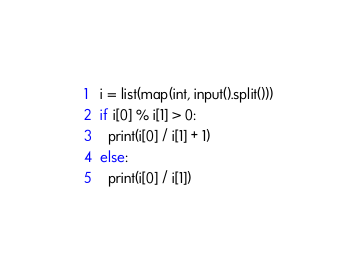<code> <loc_0><loc_0><loc_500><loc_500><_Python_>i = list(map(int, input().split()))
if i[0] % i[1] > 0:
  print(i[0] / i[1] + 1)
else:
  print(i[0] / i[1]) </code> 